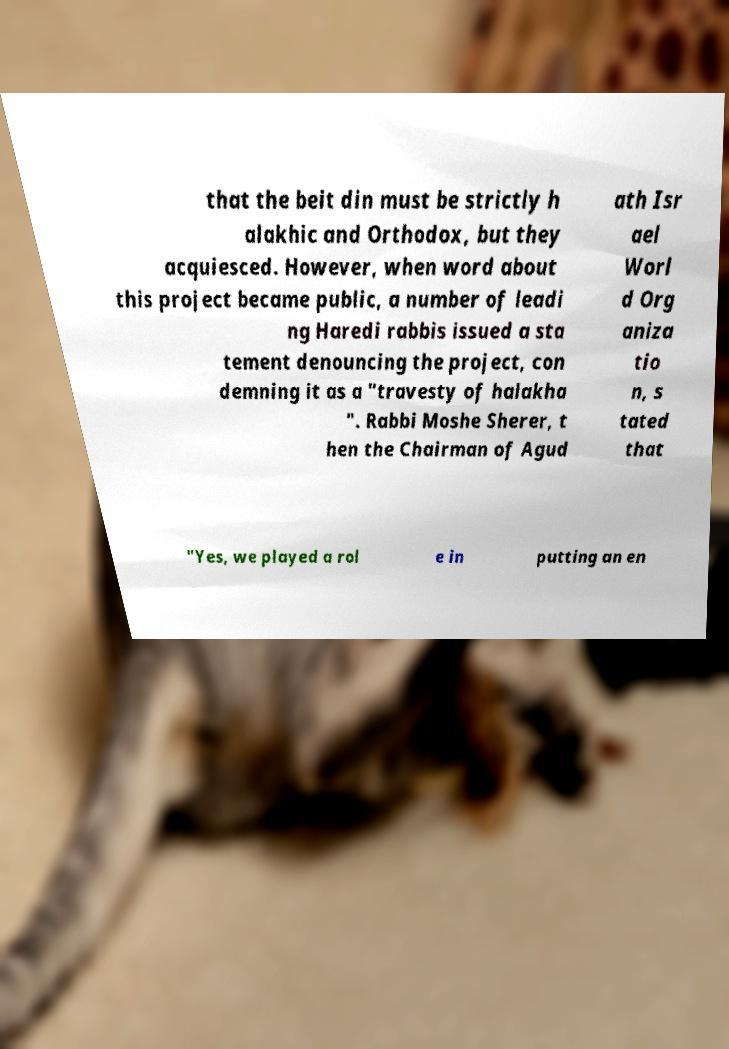For documentation purposes, I need the text within this image transcribed. Could you provide that? that the beit din must be strictly h alakhic and Orthodox, but they acquiesced. However, when word about this project became public, a number of leadi ng Haredi rabbis issued a sta tement denouncing the project, con demning it as a "travesty of halakha ". Rabbi Moshe Sherer, t hen the Chairman of Agud ath Isr ael Worl d Org aniza tio n, s tated that "Yes, we played a rol e in putting an en 